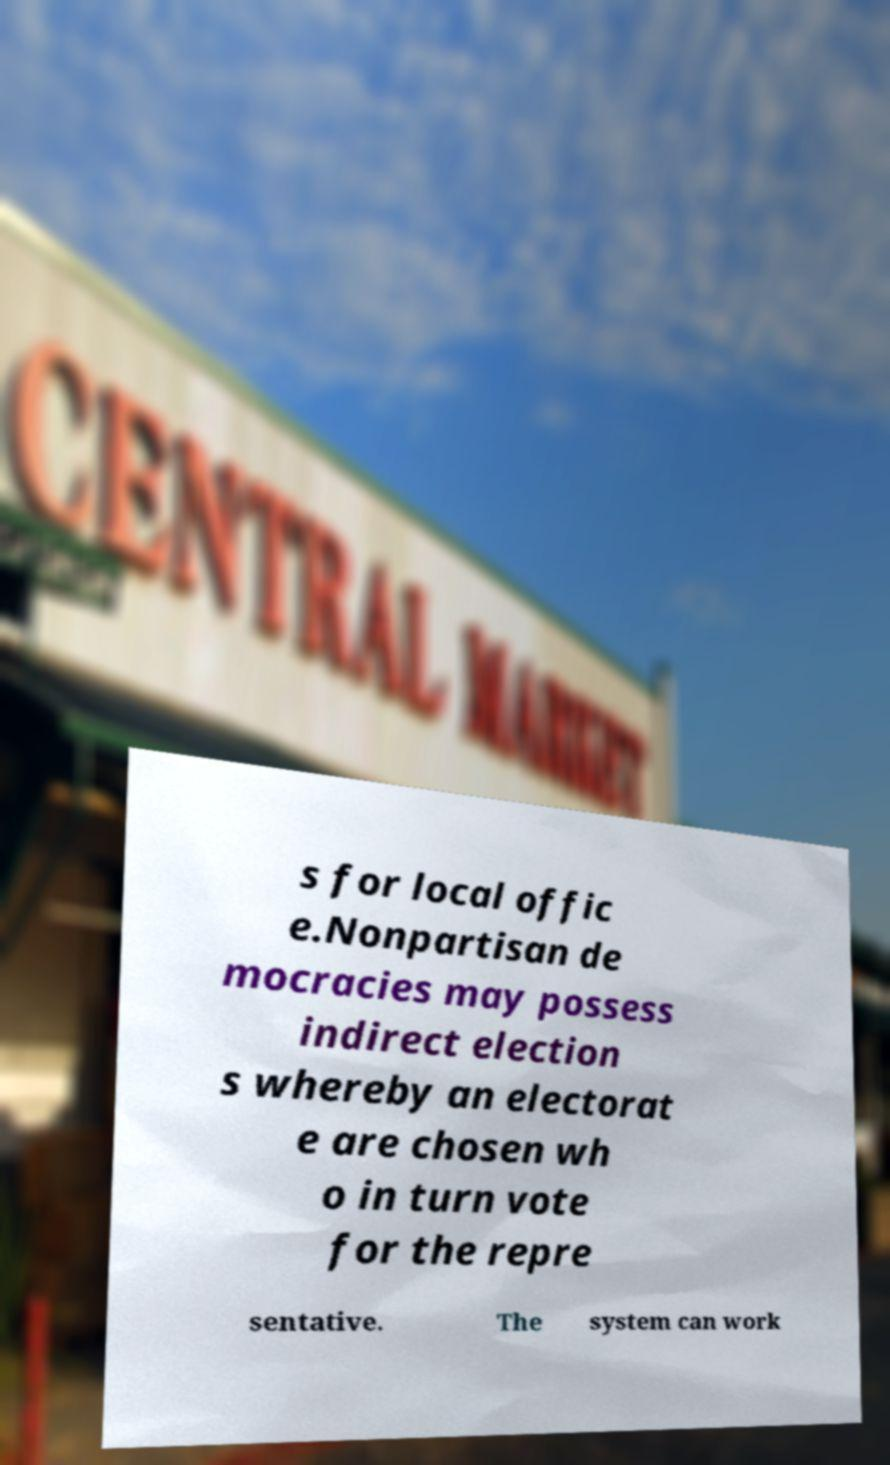Can you accurately transcribe the text from the provided image for me? s for local offic e.Nonpartisan de mocracies may possess indirect election s whereby an electorat e are chosen wh o in turn vote for the repre sentative. The system can work 